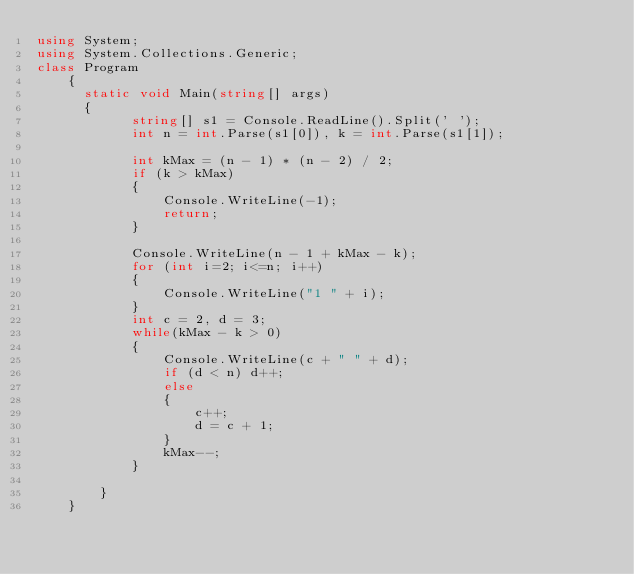Convert code to text. <code><loc_0><loc_0><loc_500><loc_500><_C#_>using System;
using System.Collections.Generic;
class Program
    {
    	static void Main(string[] args)
    	{
            string[] s1 = Console.ReadLine().Split(' ');
            int n = int.Parse(s1[0]), k = int.Parse(s1[1]);

            int kMax = (n - 1) * (n - 2) / 2;
            if (k > kMax)
            {
                Console.WriteLine(-1);
                return;
            }

            Console.WriteLine(n - 1 + kMax - k);
            for (int i=2; i<=n; i++)
            {
                Console.WriteLine("1 " + i);
            }
            int c = 2, d = 3;
            while(kMax - k > 0)
            {
                Console.WriteLine(c + " " + d);
                if (d < n) d++;
                else
                {
                    c++;
                    d = c + 1;
                }
                kMax--;
            }
            
        }
    }</code> 